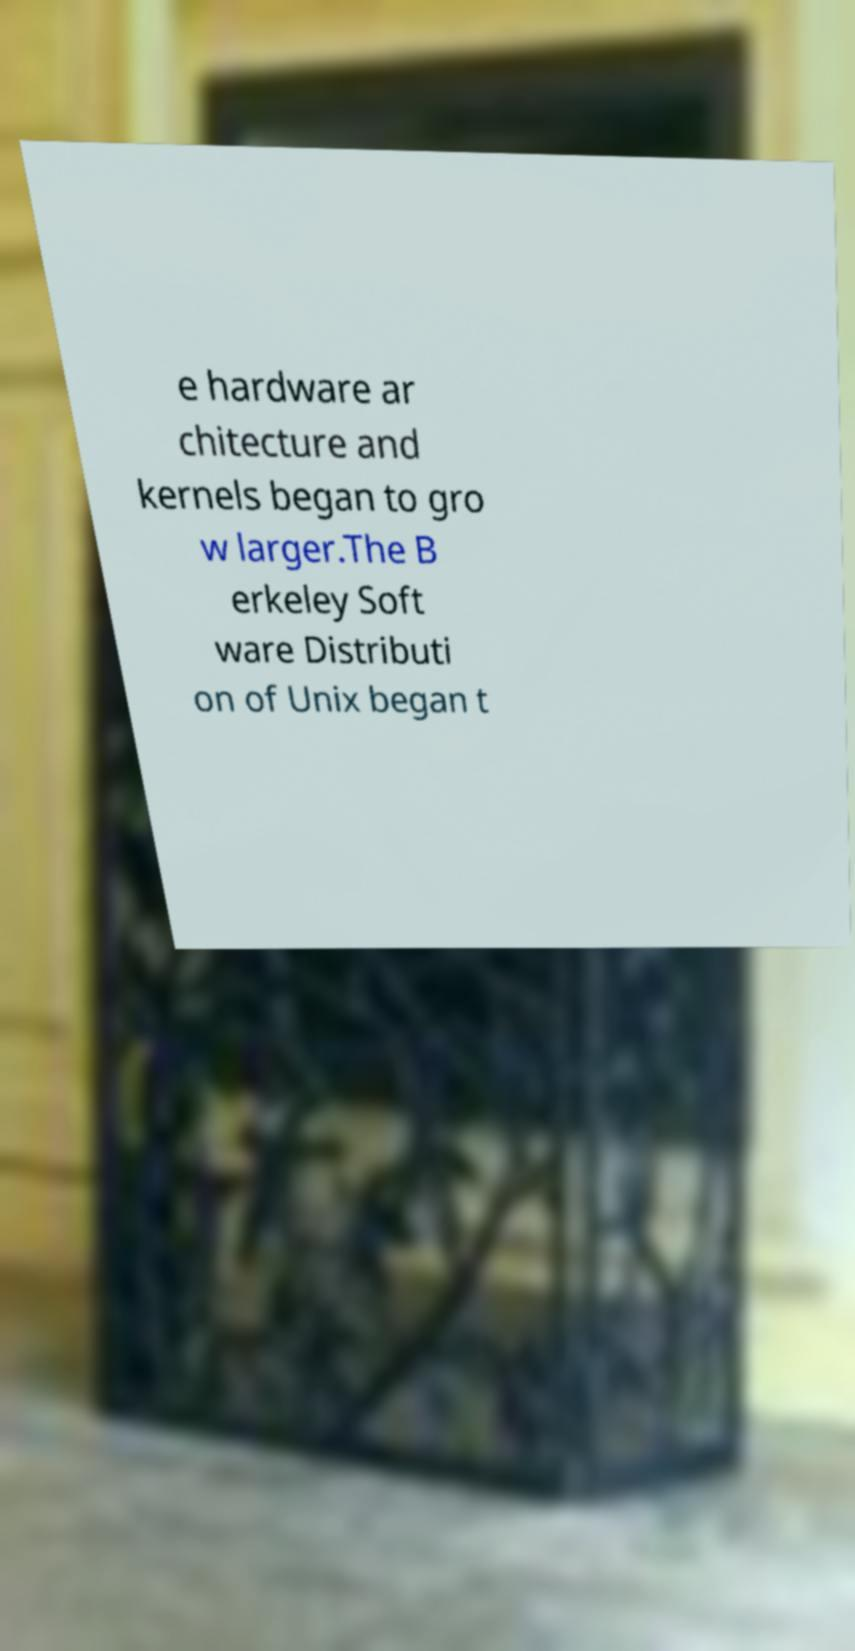Could you extract and type out the text from this image? e hardware ar chitecture and kernels began to gro w larger.The B erkeley Soft ware Distributi on of Unix began t 